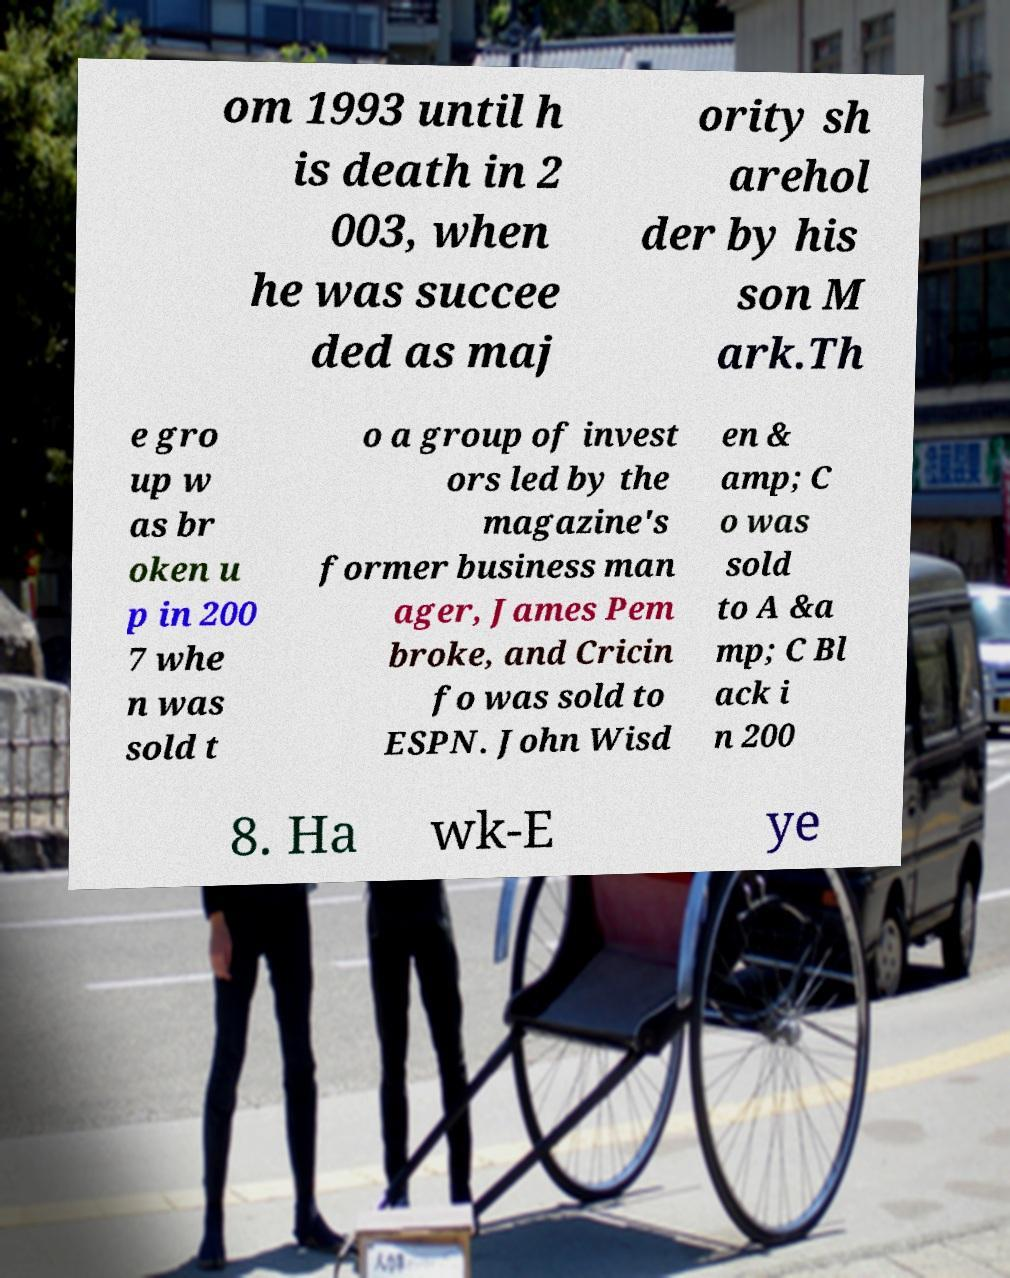For documentation purposes, I need the text within this image transcribed. Could you provide that? om 1993 until h is death in 2 003, when he was succee ded as maj ority sh arehol der by his son M ark.Th e gro up w as br oken u p in 200 7 whe n was sold t o a group of invest ors led by the magazine's former business man ager, James Pem broke, and Cricin fo was sold to ESPN. John Wisd en & amp; C o was sold to A &a mp; C Bl ack i n 200 8. Ha wk-E ye 